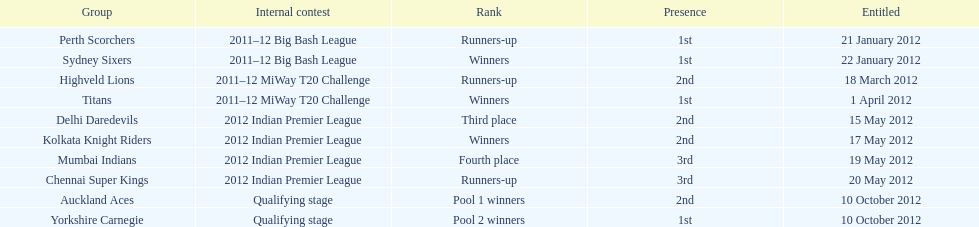Which team made their first appearance in the same tournament as the perth scorchers? Sydney Sixers. 